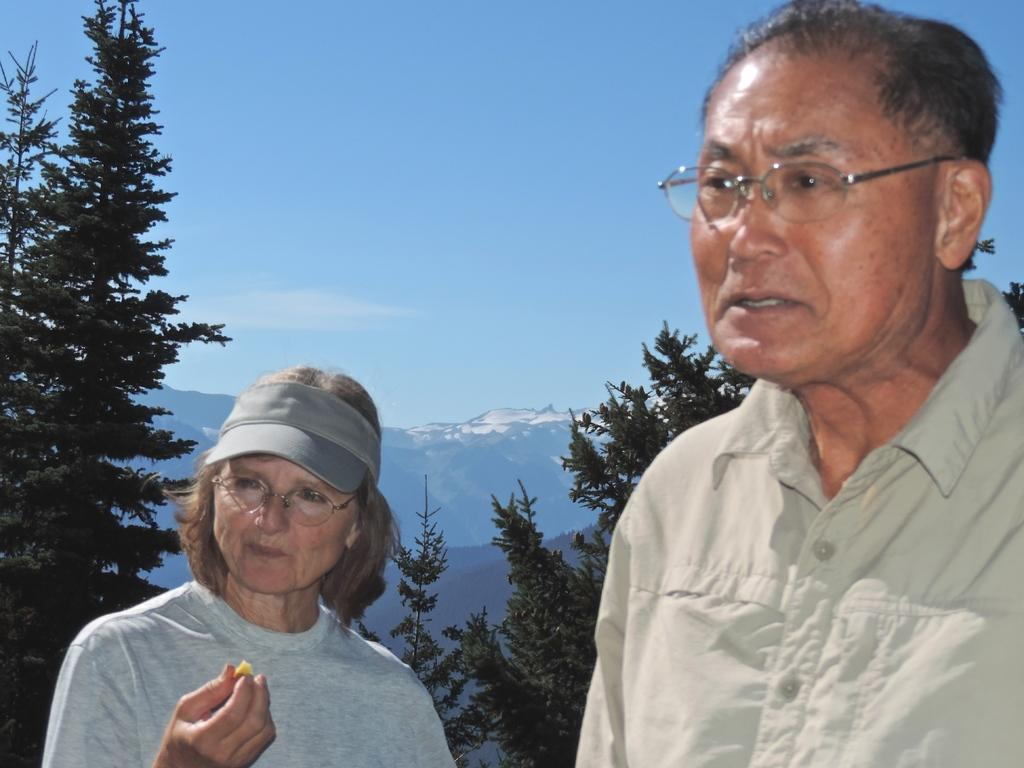How many people are in the image? There are two persons standing in the image. What is one of the persons holding in her hand? One of the persons is holding something in her hand. What can be seen in the background of the image? There are trees, mountains, and the sky visible in the background of the image. What type of tax is being discussed by the two persons in the image? There is no indication in the image that the two persons are discussing any type of tax. 